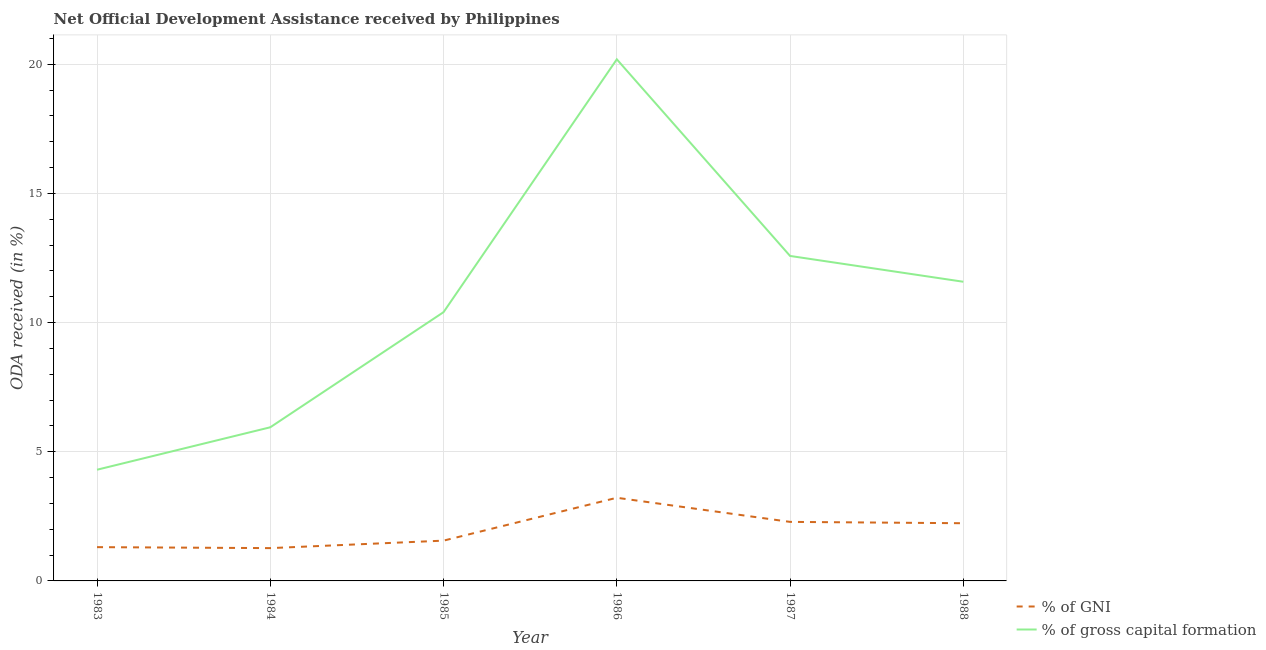How many different coloured lines are there?
Your answer should be compact. 2. What is the oda received as percentage of gni in 1983?
Make the answer very short. 1.31. Across all years, what is the maximum oda received as percentage of gross capital formation?
Provide a short and direct response. 20.19. Across all years, what is the minimum oda received as percentage of gross capital formation?
Your answer should be compact. 4.3. In which year was the oda received as percentage of gross capital formation maximum?
Provide a succinct answer. 1986. In which year was the oda received as percentage of gni minimum?
Keep it short and to the point. 1984. What is the total oda received as percentage of gross capital formation in the graph?
Keep it short and to the point. 65.01. What is the difference between the oda received as percentage of gni in 1985 and that in 1988?
Offer a very short reply. -0.67. What is the difference between the oda received as percentage of gross capital formation in 1987 and the oda received as percentage of gni in 1983?
Your response must be concise. 11.27. What is the average oda received as percentage of gni per year?
Make the answer very short. 1.98. In the year 1984, what is the difference between the oda received as percentage of gni and oda received as percentage of gross capital formation?
Make the answer very short. -4.68. What is the ratio of the oda received as percentage of gni in 1987 to that in 1988?
Offer a very short reply. 1.02. Is the oda received as percentage of gross capital formation in 1986 less than that in 1988?
Your answer should be very brief. No. What is the difference between the highest and the second highest oda received as percentage of gni?
Your answer should be compact. 0.93. What is the difference between the highest and the lowest oda received as percentage of gross capital formation?
Keep it short and to the point. 15.89. In how many years, is the oda received as percentage of gni greater than the average oda received as percentage of gni taken over all years?
Keep it short and to the point. 3. Is the sum of the oda received as percentage of gni in 1983 and 1986 greater than the maximum oda received as percentage of gross capital formation across all years?
Your answer should be very brief. No. Does the oda received as percentage of gross capital formation monotonically increase over the years?
Your answer should be very brief. No. Is the oda received as percentage of gni strictly less than the oda received as percentage of gross capital formation over the years?
Provide a short and direct response. Yes. How many lines are there?
Offer a very short reply. 2. What is the difference between two consecutive major ticks on the Y-axis?
Ensure brevity in your answer.  5. Does the graph contain any zero values?
Your answer should be compact. No. Does the graph contain grids?
Make the answer very short. Yes. How many legend labels are there?
Give a very brief answer. 2. How are the legend labels stacked?
Your response must be concise. Vertical. What is the title of the graph?
Give a very brief answer. Net Official Development Assistance received by Philippines. Does "Under-5(female)" appear as one of the legend labels in the graph?
Keep it short and to the point. No. What is the label or title of the X-axis?
Keep it short and to the point. Year. What is the label or title of the Y-axis?
Provide a succinct answer. ODA received (in %). What is the ODA received (in %) of % of GNI in 1983?
Provide a short and direct response. 1.31. What is the ODA received (in %) in % of gross capital formation in 1983?
Keep it short and to the point. 4.3. What is the ODA received (in %) in % of GNI in 1984?
Ensure brevity in your answer.  1.27. What is the ODA received (in %) of % of gross capital formation in 1984?
Make the answer very short. 5.95. What is the ODA received (in %) of % of GNI in 1985?
Offer a terse response. 1.56. What is the ODA received (in %) of % of gross capital formation in 1985?
Provide a succinct answer. 10.4. What is the ODA received (in %) in % of GNI in 1986?
Your answer should be compact. 3.22. What is the ODA received (in %) of % of gross capital formation in 1986?
Your answer should be very brief. 20.19. What is the ODA received (in %) in % of GNI in 1987?
Offer a very short reply. 2.29. What is the ODA received (in %) of % of gross capital formation in 1987?
Your answer should be very brief. 12.58. What is the ODA received (in %) of % of GNI in 1988?
Your answer should be very brief. 2.23. What is the ODA received (in %) of % of gross capital formation in 1988?
Make the answer very short. 11.58. Across all years, what is the maximum ODA received (in %) of % of GNI?
Offer a terse response. 3.22. Across all years, what is the maximum ODA received (in %) of % of gross capital formation?
Provide a succinct answer. 20.19. Across all years, what is the minimum ODA received (in %) in % of GNI?
Make the answer very short. 1.27. Across all years, what is the minimum ODA received (in %) in % of gross capital formation?
Ensure brevity in your answer.  4.3. What is the total ODA received (in %) in % of GNI in the graph?
Your answer should be compact. 11.88. What is the total ODA received (in %) in % of gross capital formation in the graph?
Offer a terse response. 65.01. What is the difference between the ODA received (in %) in % of GNI in 1983 and that in 1984?
Your response must be concise. 0.04. What is the difference between the ODA received (in %) in % of gross capital formation in 1983 and that in 1984?
Offer a very short reply. -1.64. What is the difference between the ODA received (in %) in % of GNI in 1983 and that in 1985?
Your response must be concise. -0.25. What is the difference between the ODA received (in %) of % of gross capital formation in 1983 and that in 1985?
Provide a short and direct response. -6.1. What is the difference between the ODA received (in %) in % of GNI in 1983 and that in 1986?
Your answer should be very brief. -1.91. What is the difference between the ODA received (in %) in % of gross capital formation in 1983 and that in 1986?
Offer a very short reply. -15.89. What is the difference between the ODA received (in %) of % of GNI in 1983 and that in 1987?
Keep it short and to the point. -0.98. What is the difference between the ODA received (in %) in % of gross capital formation in 1983 and that in 1987?
Keep it short and to the point. -8.28. What is the difference between the ODA received (in %) in % of GNI in 1983 and that in 1988?
Keep it short and to the point. -0.93. What is the difference between the ODA received (in %) in % of gross capital formation in 1983 and that in 1988?
Your answer should be compact. -7.28. What is the difference between the ODA received (in %) in % of GNI in 1984 and that in 1985?
Ensure brevity in your answer.  -0.29. What is the difference between the ODA received (in %) of % of gross capital formation in 1984 and that in 1985?
Your answer should be compact. -4.46. What is the difference between the ODA received (in %) in % of GNI in 1984 and that in 1986?
Offer a terse response. -1.95. What is the difference between the ODA received (in %) in % of gross capital formation in 1984 and that in 1986?
Your response must be concise. -14.24. What is the difference between the ODA received (in %) in % of GNI in 1984 and that in 1987?
Ensure brevity in your answer.  -1.02. What is the difference between the ODA received (in %) in % of gross capital formation in 1984 and that in 1987?
Ensure brevity in your answer.  -6.63. What is the difference between the ODA received (in %) in % of GNI in 1984 and that in 1988?
Give a very brief answer. -0.96. What is the difference between the ODA received (in %) in % of gross capital formation in 1984 and that in 1988?
Provide a short and direct response. -5.63. What is the difference between the ODA received (in %) of % of GNI in 1985 and that in 1986?
Your answer should be compact. -1.66. What is the difference between the ODA received (in %) of % of gross capital formation in 1985 and that in 1986?
Provide a short and direct response. -9.79. What is the difference between the ODA received (in %) in % of GNI in 1985 and that in 1987?
Ensure brevity in your answer.  -0.73. What is the difference between the ODA received (in %) of % of gross capital formation in 1985 and that in 1987?
Keep it short and to the point. -2.18. What is the difference between the ODA received (in %) of % of GNI in 1985 and that in 1988?
Make the answer very short. -0.67. What is the difference between the ODA received (in %) in % of gross capital formation in 1985 and that in 1988?
Offer a terse response. -1.18. What is the difference between the ODA received (in %) in % of GNI in 1986 and that in 1987?
Provide a short and direct response. 0.93. What is the difference between the ODA received (in %) in % of gross capital formation in 1986 and that in 1987?
Provide a succinct answer. 7.61. What is the difference between the ODA received (in %) in % of GNI in 1986 and that in 1988?
Your answer should be very brief. 0.99. What is the difference between the ODA received (in %) in % of gross capital formation in 1986 and that in 1988?
Make the answer very short. 8.61. What is the difference between the ODA received (in %) in % of GNI in 1987 and that in 1988?
Provide a short and direct response. 0.05. What is the difference between the ODA received (in %) of % of gross capital formation in 1987 and that in 1988?
Ensure brevity in your answer.  1. What is the difference between the ODA received (in %) in % of GNI in 1983 and the ODA received (in %) in % of gross capital formation in 1984?
Make the answer very short. -4.64. What is the difference between the ODA received (in %) in % of GNI in 1983 and the ODA received (in %) in % of gross capital formation in 1985?
Keep it short and to the point. -9.1. What is the difference between the ODA received (in %) in % of GNI in 1983 and the ODA received (in %) in % of gross capital formation in 1986?
Your answer should be compact. -18.88. What is the difference between the ODA received (in %) of % of GNI in 1983 and the ODA received (in %) of % of gross capital formation in 1987?
Keep it short and to the point. -11.27. What is the difference between the ODA received (in %) of % of GNI in 1983 and the ODA received (in %) of % of gross capital formation in 1988?
Give a very brief answer. -10.27. What is the difference between the ODA received (in %) of % of GNI in 1984 and the ODA received (in %) of % of gross capital formation in 1985?
Your answer should be compact. -9.13. What is the difference between the ODA received (in %) in % of GNI in 1984 and the ODA received (in %) in % of gross capital formation in 1986?
Offer a very short reply. -18.92. What is the difference between the ODA received (in %) of % of GNI in 1984 and the ODA received (in %) of % of gross capital formation in 1987?
Keep it short and to the point. -11.31. What is the difference between the ODA received (in %) in % of GNI in 1984 and the ODA received (in %) in % of gross capital formation in 1988?
Give a very brief answer. -10.31. What is the difference between the ODA received (in %) in % of GNI in 1985 and the ODA received (in %) in % of gross capital formation in 1986?
Keep it short and to the point. -18.63. What is the difference between the ODA received (in %) of % of GNI in 1985 and the ODA received (in %) of % of gross capital formation in 1987?
Offer a very short reply. -11.02. What is the difference between the ODA received (in %) of % of GNI in 1985 and the ODA received (in %) of % of gross capital formation in 1988?
Keep it short and to the point. -10.02. What is the difference between the ODA received (in %) in % of GNI in 1986 and the ODA received (in %) in % of gross capital formation in 1987?
Provide a succinct answer. -9.36. What is the difference between the ODA received (in %) in % of GNI in 1986 and the ODA received (in %) in % of gross capital formation in 1988?
Keep it short and to the point. -8.36. What is the difference between the ODA received (in %) in % of GNI in 1987 and the ODA received (in %) in % of gross capital formation in 1988?
Your response must be concise. -9.3. What is the average ODA received (in %) in % of GNI per year?
Ensure brevity in your answer.  1.98. What is the average ODA received (in %) of % of gross capital formation per year?
Your answer should be compact. 10.84. In the year 1983, what is the difference between the ODA received (in %) of % of GNI and ODA received (in %) of % of gross capital formation?
Keep it short and to the point. -3. In the year 1984, what is the difference between the ODA received (in %) of % of GNI and ODA received (in %) of % of gross capital formation?
Your answer should be very brief. -4.68. In the year 1985, what is the difference between the ODA received (in %) in % of GNI and ODA received (in %) in % of gross capital formation?
Ensure brevity in your answer.  -8.85. In the year 1986, what is the difference between the ODA received (in %) in % of GNI and ODA received (in %) in % of gross capital formation?
Your answer should be compact. -16.97. In the year 1987, what is the difference between the ODA received (in %) in % of GNI and ODA received (in %) in % of gross capital formation?
Give a very brief answer. -10.3. In the year 1988, what is the difference between the ODA received (in %) in % of GNI and ODA received (in %) in % of gross capital formation?
Give a very brief answer. -9.35. What is the ratio of the ODA received (in %) of % of GNI in 1983 to that in 1984?
Provide a short and direct response. 1.03. What is the ratio of the ODA received (in %) in % of gross capital formation in 1983 to that in 1984?
Offer a terse response. 0.72. What is the ratio of the ODA received (in %) of % of GNI in 1983 to that in 1985?
Keep it short and to the point. 0.84. What is the ratio of the ODA received (in %) in % of gross capital formation in 1983 to that in 1985?
Your answer should be compact. 0.41. What is the ratio of the ODA received (in %) in % of GNI in 1983 to that in 1986?
Give a very brief answer. 0.41. What is the ratio of the ODA received (in %) of % of gross capital formation in 1983 to that in 1986?
Ensure brevity in your answer.  0.21. What is the ratio of the ODA received (in %) in % of GNI in 1983 to that in 1987?
Provide a succinct answer. 0.57. What is the ratio of the ODA received (in %) of % of gross capital formation in 1983 to that in 1987?
Make the answer very short. 0.34. What is the ratio of the ODA received (in %) in % of GNI in 1983 to that in 1988?
Your answer should be compact. 0.59. What is the ratio of the ODA received (in %) of % of gross capital formation in 1983 to that in 1988?
Provide a short and direct response. 0.37. What is the ratio of the ODA received (in %) of % of GNI in 1984 to that in 1985?
Offer a terse response. 0.81. What is the ratio of the ODA received (in %) in % of gross capital formation in 1984 to that in 1985?
Provide a short and direct response. 0.57. What is the ratio of the ODA received (in %) in % of GNI in 1984 to that in 1986?
Your answer should be very brief. 0.39. What is the ratio of the ODA received (in %) of % of gross capital formation in 1984 to that in 1986?
Your response must be concise. 0.29. What is the ratio of the ODA received (in %) in % of GNI in 1984 to that in 1987?
Your response must be concise. 0.56. What is the ratio of the ODA received (in %) of % of gross capital formation in 1984 to that in 1987?
Offer a terse response. 0.47. What is the ratio of the ODA received (in %) of % of GNI in 1984 to that in 1988?
Offer a very short reply. 0.57. What is the ratio of the ODA received (in %) of % of gross capital formation in 1984 to that in 1988?
Give a very brief answer. 0.51. What is the ratio of the ODA received (in %) of % of GNI in 1985 to that in 1986?
Your answer should be very brief. 0.48. What is the ratio of the ODA received (in %) in % of gross capital formation in 1985 to that in 1986?
Make the answer very short. 0.52. What is the ratio of the ODA received (in %) of % of GNI in 1985 to that in 1987?
Your response must be concise. 0.68. What is the ratio of the ODA received (in %) in % of gross capital formation in 1985 to that in 1987?
Provide a short and direct response. 0.83. What is the ratio of the ODA received (in %) of % of GNI in 1985 to that in 1988?
Provide a succinct answer. 0.7. What is the ratio of the ODA received (in %) of % of gross capital formation in 1985 to that in 1988?
Provide a succinct answer. 0.9. What is the ratio of the ODA received (in %) in % of GNI in 1986 to that in 1987?
Give a very brief answer. 1.41. What is the ratio of the ODA received (in %) in % of gross capital formation in 1986 to that in 1987?
Keep it short and to the point. 1.6. What is the ratio of the ODA received (in %) in % of GNI in 1986 to that in 1988?
Your answer should be very brief. 1.44. What is the ratio of the ODA received (in %) in % of gross capital formation in 1986 to that in 1988?
Give a very brief answer. 1.74. What is the ratio of the ODA received (in %) of % of GNI in 1987 to that in 1988?
Give a very brief answer. 1.02. What is the ratio of the ODA received (in %) in % of gross capital formation in 1987 to that in 1988?
Make the answer very short. 1.09. What is the difference between the highest and the second highest ODA received (in %) in % of GNI?
Your answer should be compact. 0.93. What is the difference between the highest and the second highest ODA received (in %) in % of gross capital formation?
Offer a very short reply. 7.61. What is the difference between the highest and the lowest ODA received (in %) in % of GNI?
Keep it short and to the point. 1.95. What is the difference between the highest and the lowest ODA received (in %) of % of gross capital formation?
Provide a succinct answer. 15.89. 